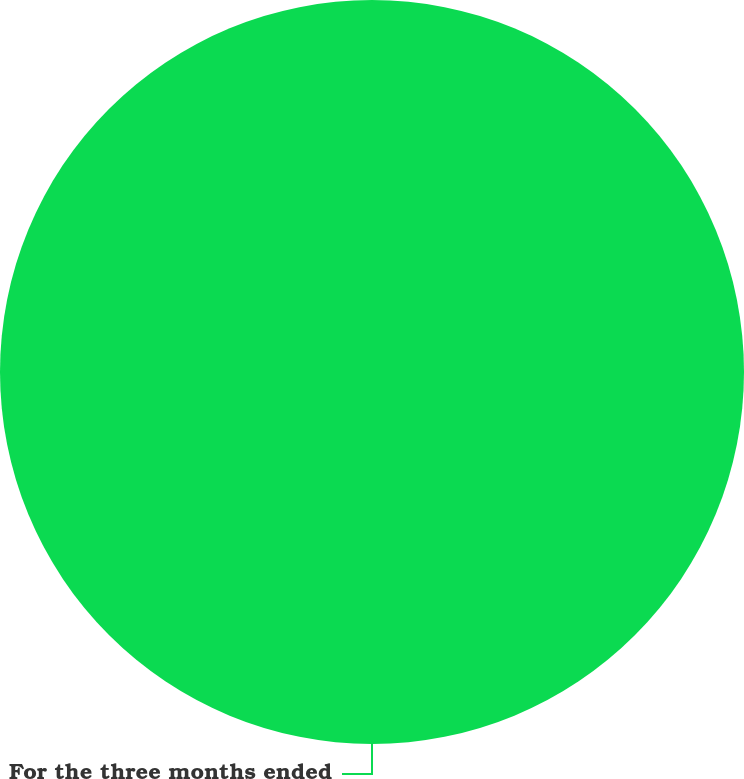<chart> <loc_0><loc_0><loc_500><loc_500><pie_chart><fcel>For the three months ended<nl><fcel>100.0%<nl></chart> 